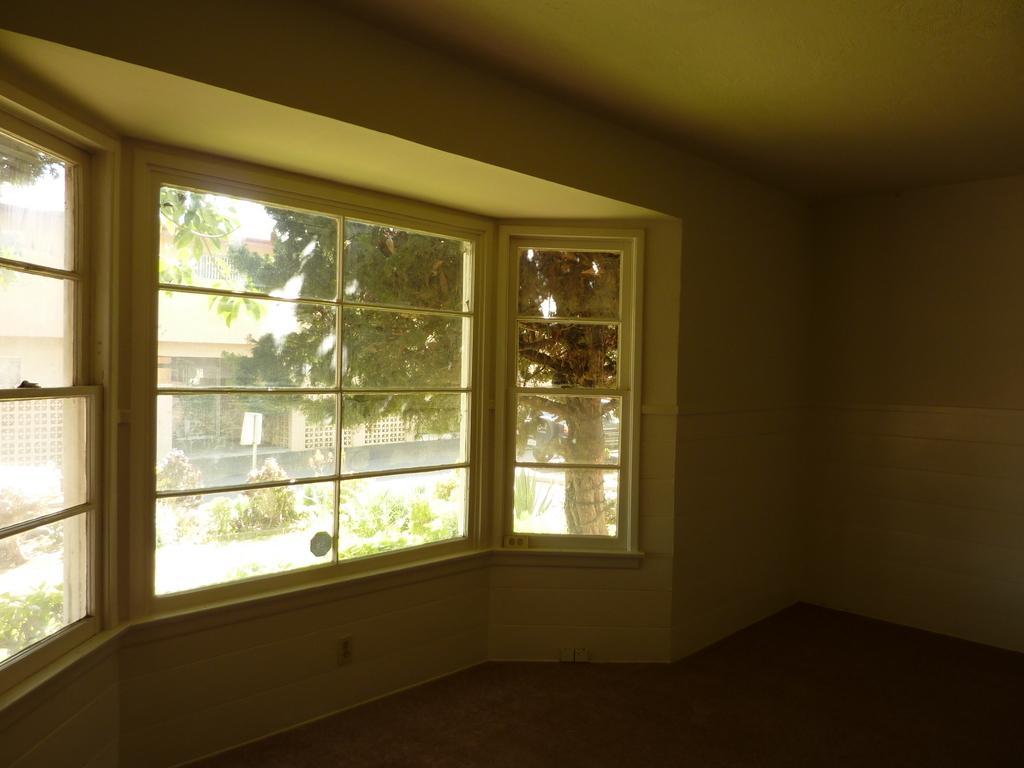Can you describe this image briefly? In this image I can see a buildings and glass windows. The wall is in white and green color. Back I can see a trees and white color board. 